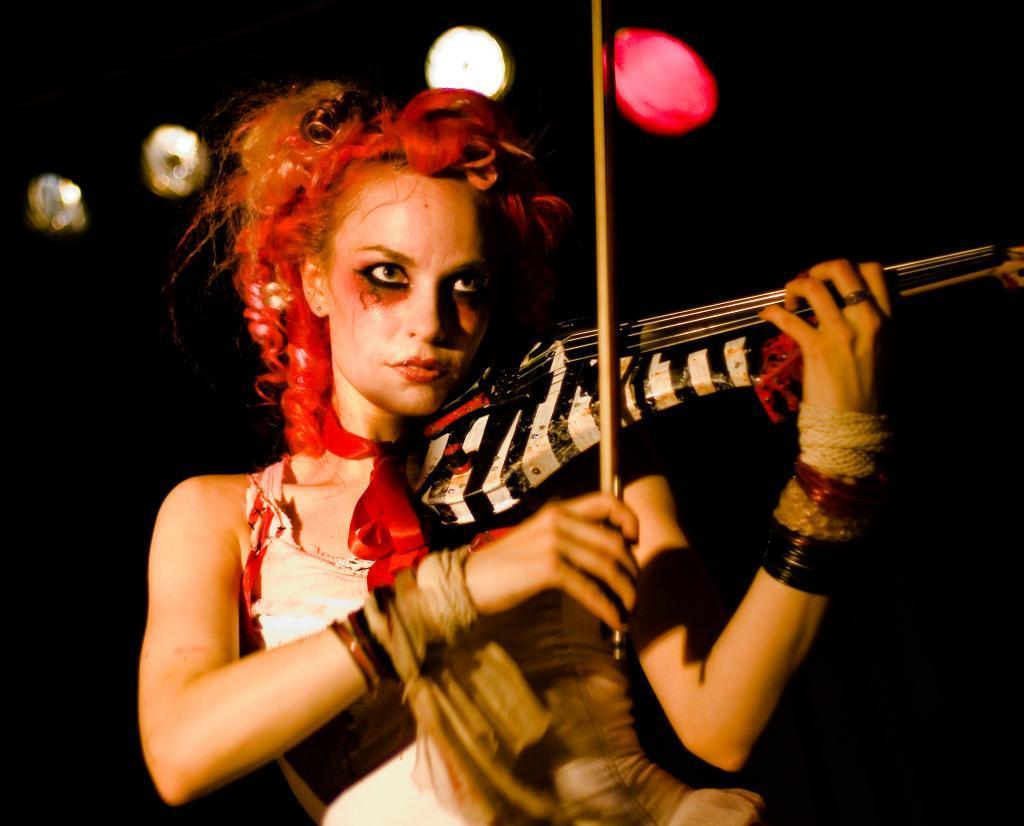Who is the main subject in the image? There is a woman in the image. What is the woman wearing? The woman is wearing a white dress. What is the woman holding in the image? The woman is holding a music instrument. What type of event might the woman be attending, based on her attire? The woman is in fancy dress, which suggests she might be attending a formal event or party. Can you describe the background in the image? The background behind the woman is black with lights. Where is the cannon located in the image? There is no cannon present in the image. What type of door can be seen in the image? There is no door visible in the image. 